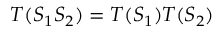Convert formula to latex. <formula><loc_0><loc_0><loc_500><loc_500>T ( S _ { 1 } S _ { 2 } ) = T ( S _ { 1 } ) T ( S _ { 2 } )</formula> 